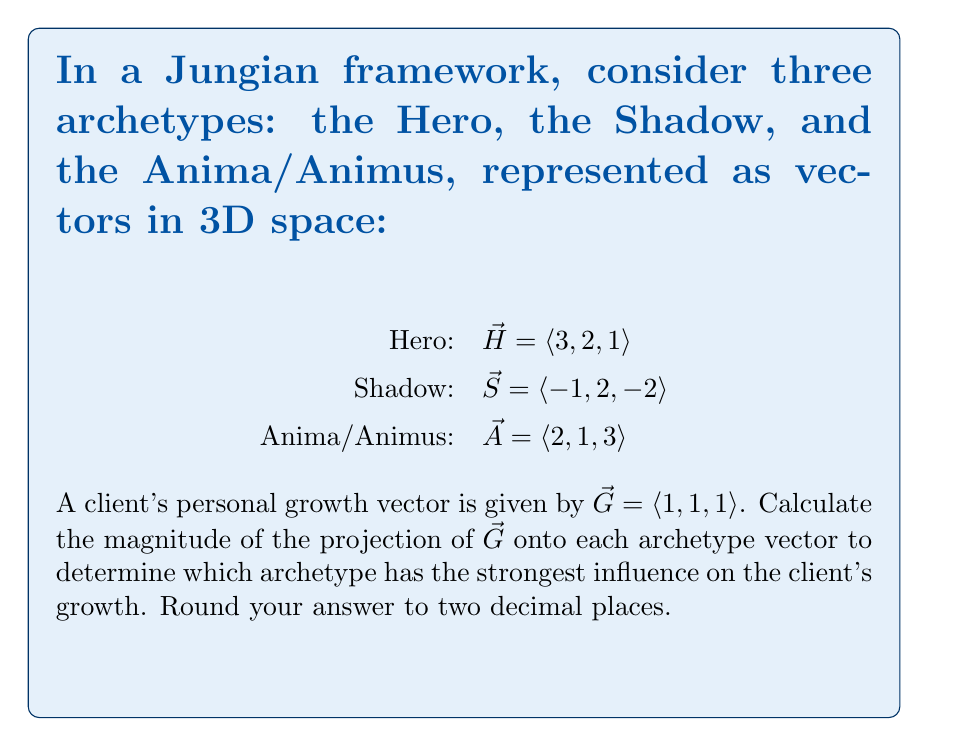What is the answer to this math problem? To solve this problem, we need to calculate the projection of $\vec{G}$ onto each archetype vector and compare their magnitudes. The formula for vector projection is:

$$\text{proj}_{\vec{u}}\vec{v} = \frac{\vec{v} \cdot \vec{u}}{\|\vec{u}\|^2}\vec{u}$$

Where $\vec{v}$ is the vector being projected (in this case, $\vec{G}$) and $\vec{u}$ is the vector onto which we're projecting.

Step 1: Calculate the magnitude of the projection onto the Hero vector $\vec{H}$:

$\|\text{proj}_{\vec{H}}\vec{G}\| = \frac{|\vec{G} \cdot \vec{H}|}{\|\vec{H}\|} = \frac{|(1,1,1) \cdot (3,2,1)|}{\sqrt{3^2 + 2^2 + 1^2}} = \frac{|6|}{\sqrt{14}} \approx 1.60$

Step 2: Calculate the magnitude of the projection onto the Shadow vector $\vec{S}$:

$\|\text{proj}_{\vec{S}}\vec{G}\| = \frac{|\vec{G} \cdot \vec{S}|}{\|\vec{S}\|} = \frac{|(1,1,1) \cdot (-1,2,-2)|}{\sqrt{(-1)^2 + 2^2 + (-2)^2}} = \frac{|-1|}{\sqrt{9}} = \frac{1}{3} \approx 0.33$

Step 3: Calculate the magnitude of the projection onto the Anima/Animus vector $\vec{A}$:

$\|\text{proj}_{\vec{A}}\vec{G}\| = \frac{|\vec{G} \cdot \vec{A}|}{\|\vec{A}\|} = \frac{|(1,1,1) \cdot (2,1,3)|}{\sqrt{2^2 + 1^2 + 3^2}} = \frac{|6|}{\sqrt{14}} \approx 1.60$

Step 4: Compare the magnitudes of the projections:

Hero: 1.60
Shadow: 0.33
Anima/Animus: 1.60

The Hero and Anima/Animus archetypes have the largest and equal projection magnitudes, indicating they have the strongest influence on the client's growth.
Answer: Hero and Anima/Animus (1.60) 